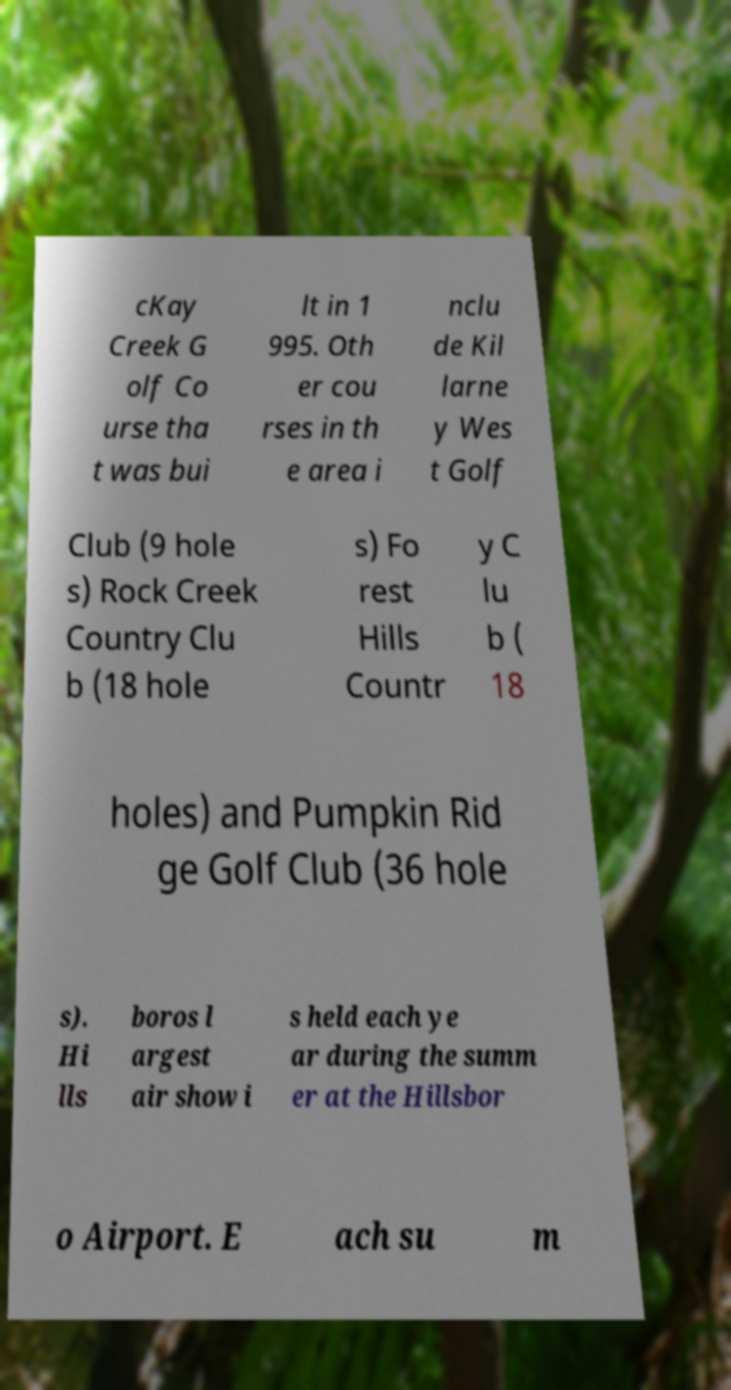Please identify and transcribe the text found in this image. cKay Creek G olf Co urse tha t was bui lt in 1 995. Oth er cou rses in th e area i nclu de Kil larne y Wes t Golf Club (9 hole s) Rock Creek Country Clu b (18 hole s) Fo rest Hills Countr y C lu b ( 18 holes) and Pumpkin Rid ge Golf Club (36 hole s). Hi lls boros l argest air show i s held each ye ar during the summ er at the Hillsbor o Airport. E ach su m 